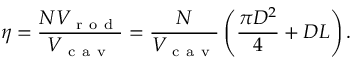Convert formula to latex. <formula><loc_0><loc_0><loc_500><loc_500>\eta = \frac { N V _ { r o d } } { V _ { c a v } } = \frac { N } { V _ { c a v } } \left ( \frac { \pi D ^ { 2 } } { 4 } + D L \right ) .</formula> 